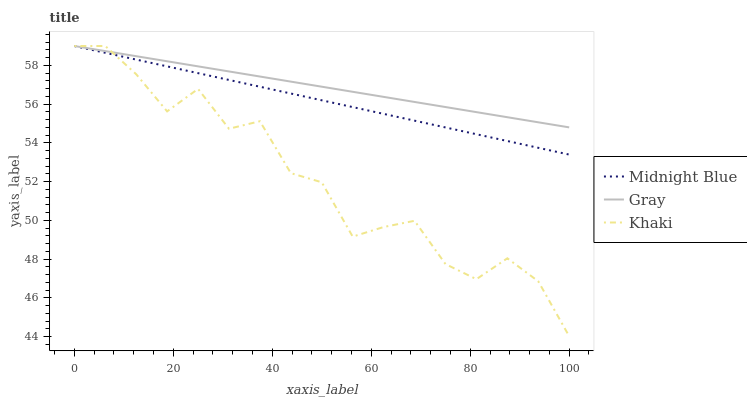Does Midnight Blue have the minimum area under the curve?
Answer yes or no. No. Does Midnight Blue have the maximum area under the curve?
Answer yes or no. No. Is Midnight Blue the smoothest?
Answer yes or no. No. Is Midnight Blue the roughest?
Answer yes or no. No. Does Midnight Blue have the lowest value?
Answer yes or no. No. 